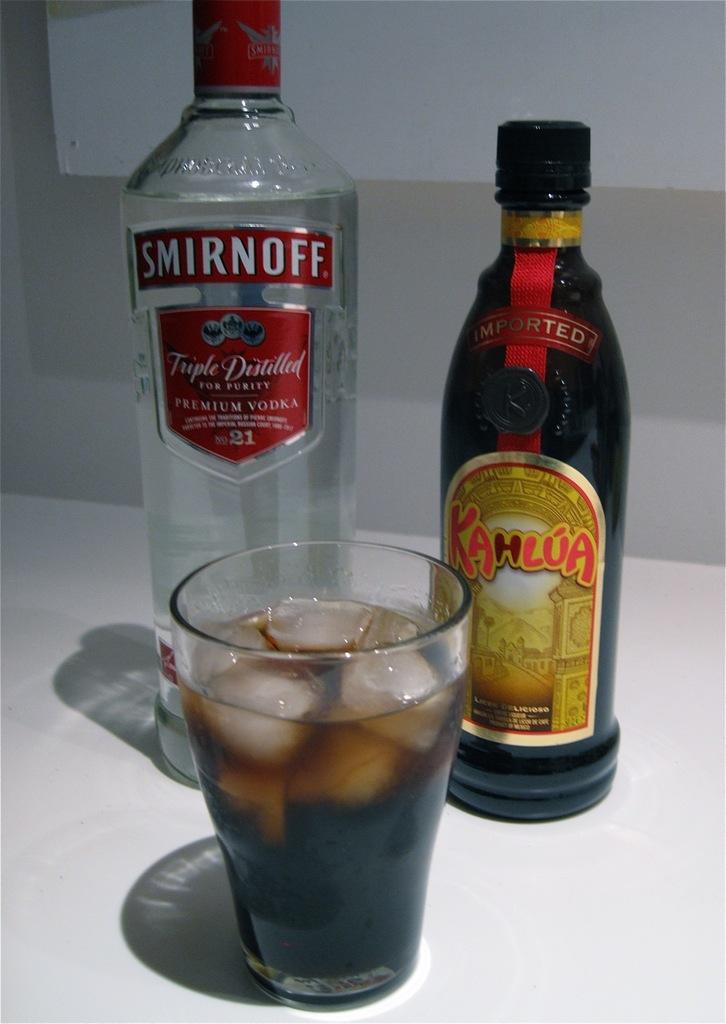What brand of vodka?
Your answer should be compact. Smirnoff. What is the name on the right bottle?
Make the answer very short. Kahlua. 